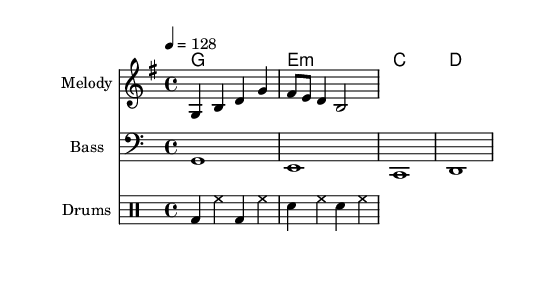What is the key signature of this music? The key signature is G major, which has one sharp (F#). It can be identified by looking at the start of the music sheet, where the key signature is indicated.
Answer: G major What is the time signature of this music? The time signature is 4/4, which means there are four beats in a measure and the quarter note gets one beat. This can be found in the top left corner of the sheet music.
Answer: 4/4 What is the tempo marking for this piece? The tempo marking indicates a speed of 128 beats per minute. This is noted in the score as "4 = 128" which specifies the tempo for the quarter note.
Answer: 128 What chords are being played in the harmony part? The harmony consists of G major, E minor, C major, and D major. These can be identified by looking at the chord symbols above the staff in the "ChordNames" section.
Answer: G, E minor, C, D How many measures are in the melody? The melody contains four measures, indicated by the grouping of notes separated by vertical lines (bar lines). Each section of notes enclosed between bar lines counts as one measure.
Answer: 4 Which instruments are featured in this piece? The instruments featured are Melody, Bass, and Drums. This can be seen in the score layout where each staff is labeled accordingly; they correspond to different instrumental parts.
Answer: Melody, Bass, Drums What is the rhythmic pattern of the drum part in the first measure? The drum part in the first measure features a kick drum played twice (bd) and hi-hats played twice (hh). By examining the drum notation, we can discern the specific hits and their order within the measure.
Answer: bd, hh 